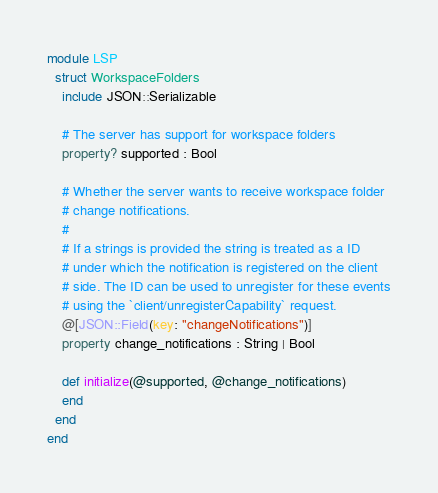<code> <loc_0><loc_0><loc_500><loc_500><_Crystal_>module LSP
  struct WorkspaceFolders
    include JSON::Serializable

    # The server has support for workspace folders
    property? supported : Bool

    # Whether the server wants to receive workspace folder
    # change notifications.
    #
    # If a strings is provided the string is treated as a ID
    # under which the notification is registered on the client
    # side. The ID can be used to unregister for these events
    # using the `client/unregisterCapability` request.
    @[JSON::Field(key: "changeNotifications")]
    property change_notifications : String | Bool

    def initialize(@supported, @change_notifications)
    end
  end
end
</code> 